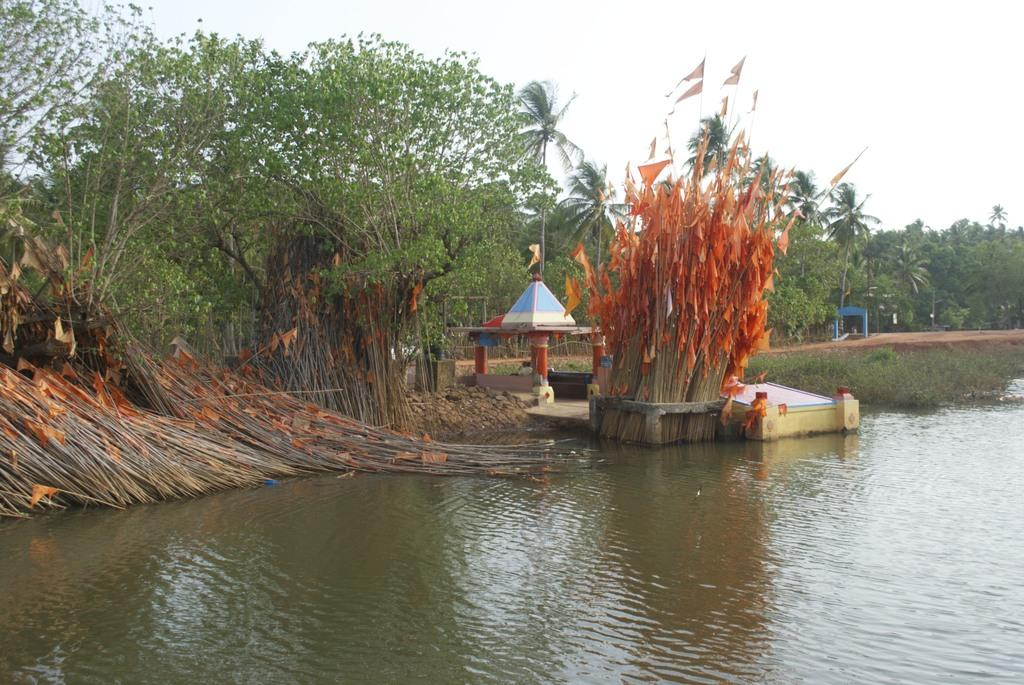What type of body of water is present in the image? There is a lake in the image. What can be seen in the background of the image? There are wooden sticks with flags, trees, and a temple in the background. What is visible in the sky in the image? The sky is visible in the image. Who is the achiever talking to in the image? There is no achiever or conversation present in the image. How many knots are tied on the wooden sticks with flags in the image? The number of knots on the wooden sticks with flags cannot be determined from the image. 